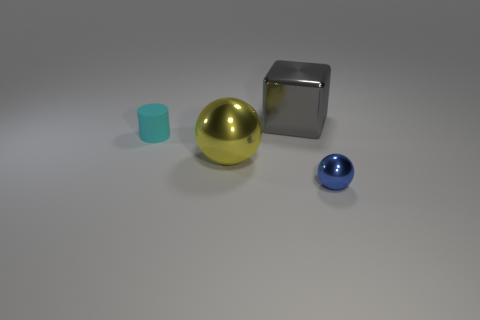There is a small blue metallic thing; what shape is it?
Give a very brief answer. Sphere. Is there anything else that has the same material as the cyan cylinder?
Keep it short and to the point. No. Do the cylinder and the yellow ball have the same material?
Your answer should be very brief. No. There is a matte cylinder behind the metallic sphere left of the large metallic cube; are there any big spheres to the right of it?
Offer a terse response. Yes. How many other things are the same shape as the cyan object?
Provide a succinct answer. 0. There is a object that is both in front of the cyan matte cylinder and left of the small blue ball; what is its shape?
Provide a short and direct response. Sphere. The tiny thing to the right of the small thing on the left side of the ball that is in front of the yellow metal sphere is what color?
Make the answer very short. Blue. Are there more metal objects that are behind the big yellow sphere than large metal spheres in front of the tiny metal ball?
Your answer should be very brief. Yes. What number of other objects are there of the same size as the yellow object?
Provide a short and direct response. 1. What material is the yellow thing on the left side of the large thing that is behind the small cyan matte thing?
Provide a short and direct response. Metal. 